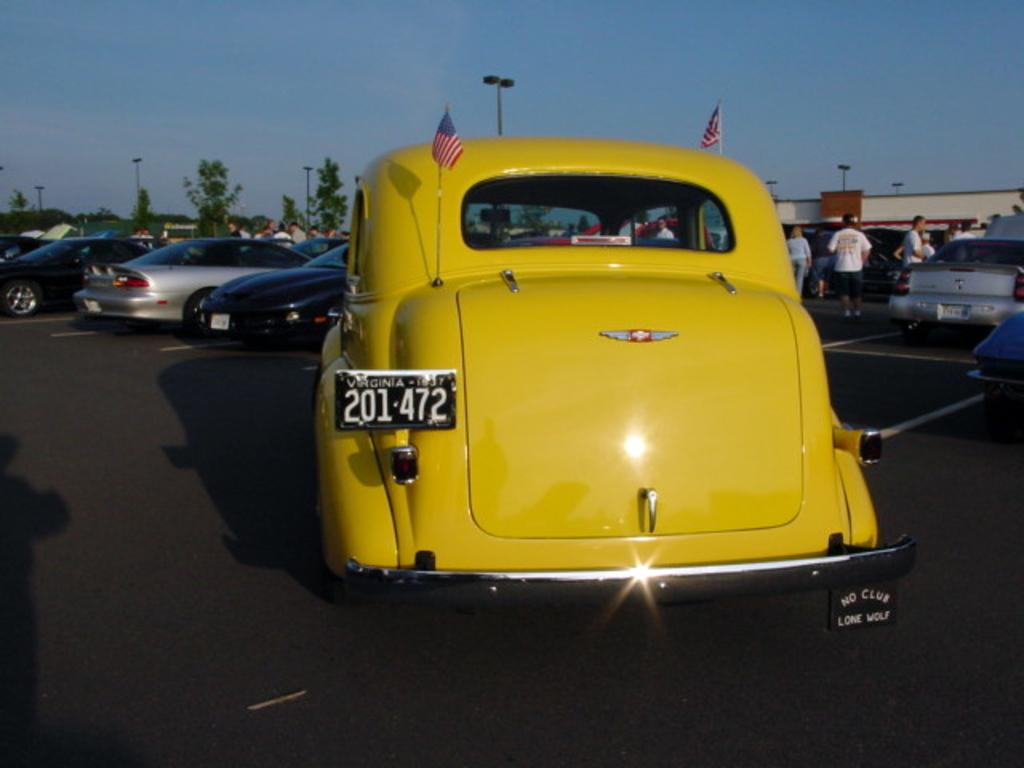What is the main subject in the foreground of the image? There is a car in the foreground of the image. What can be seen in the background of the image? There are cars, people, a building, trees, poles, and the sky visible in the background of the image. How many cars are visible in the image? There is one car in the foreground and multiple cars in the background, so at least two cars are visible in the image. What type of structure is present in the background of the image? There is a building in the background of the image. What type of scent can be smelled coming from the store in the image? There is no store present in the image, so it is not possible to determine what scent might be smelled. 